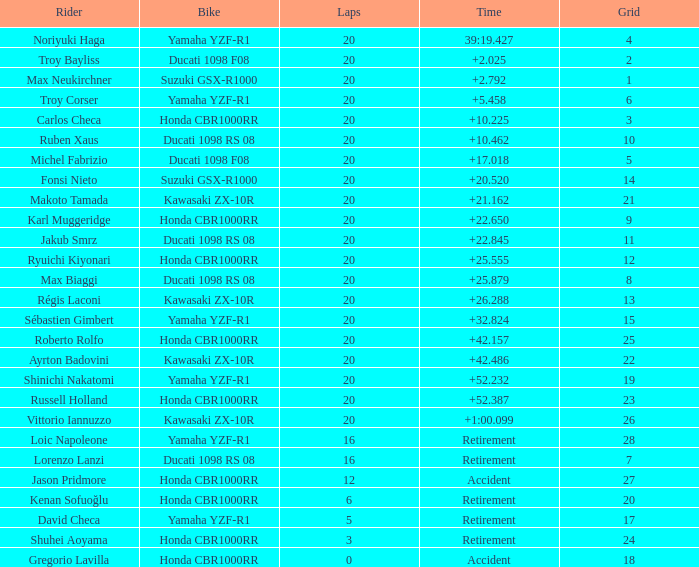What is the time of Max Biaggi with more than 2 grids, 20 laps? 25.879. Would you mind parsing the complete table? {'header': ['Rider', 'Bike', 'Laps', 'Time', 'Grid'], 'rows': [['Noriyuki Haga', 'Yamaha YZF-R1', '20', '39:19.427', '4'], ['Troy Bayliss', 'Ducati 1098 F08', '20', '+2.025', '2'], ['Max Neukirchner', 'Suzuki GSX-R1000', '20', '+2.792', '1'], ['Troy Corser', 'Yamaha YZF-R1', '20', '+5.458', '6'], ['Carlos Checa', 'Honda CBR1000RR', '20', '+10.225', '3'], ['Ruben Xaus', 'Ducati 1098 RS 08', '20', '+10.462', '10'], ['Michel Fabrizio', 'Ducati 1098 F08', '20', '+17.018', '5'], ['Fonsi Nieto', 'Suzuki GSX-R1000', '20', '+20.520', '14'], ['Makoto Tamada', 'Kawasaki ZX-10R', '20', '+21.162', '21'], ['Karl Muggeridge', 'Honda CBR1000RR', '20', '+22.650', '9'], ['Jakub Smrz', 'Ducati 1098 RS 08', '20', '+22.845', '11'], ['Ryuichi Kiyonari', 'Honda CBR1000RR', '20', '+25.555', '12'], ['Max Biaggi', 'Ducati 1098 RS 08', '20', '+25.879', '8'], ['Régis Laconi', 'Kawasaki ZX-10R', '20', '+26.288', '13'], ['Sébastien Gimbert', 'Yamaha YZF-R1', '20', '+32.824', '15'], ['Roberto Rolfo', 'Honda CBR1000RR', '20', '+42.157', '25'], ['Ayrton Badovini', 'Kawasaki ZX-10R', '20', '+42.486', '22'], ['Shinichi Nakatomi', 'Yamaha YZF-R1', '20', '+52.232', '19'], ['Russell Holland', 'Honda CBR1000RR', '20', '+52.387', '23'], ['Vittorio Iannuzzo', 'Kawasaki ZX-10R', '20', '+1:00.099', '26'], ['Loic Napoleone', 'Yamaha YZF-R1', '16', 'Retirement', '28'], ['Lorenzo Lanzi', 'Ducati 1098 RS 08', '16', 'Retirement', '7'], ['Jason Pridmore', 'Honda CBR1000RR', '12', 'Accident', '27'], ['Kenan Sofuoğlu', 'Honda CBR1000RR', '6', 'Retirement', '20'], ['David Checa', 'Yamaha YZF-R1', '5', 'Retirement', '17'], ['Shuhei Aoyama', 'Honda CBR1000RR', '3', 'Retirement', '24'], ['Gregorio Lavilla', 'Honda CBR1000RR', '0', 'Accident', '18']]} 